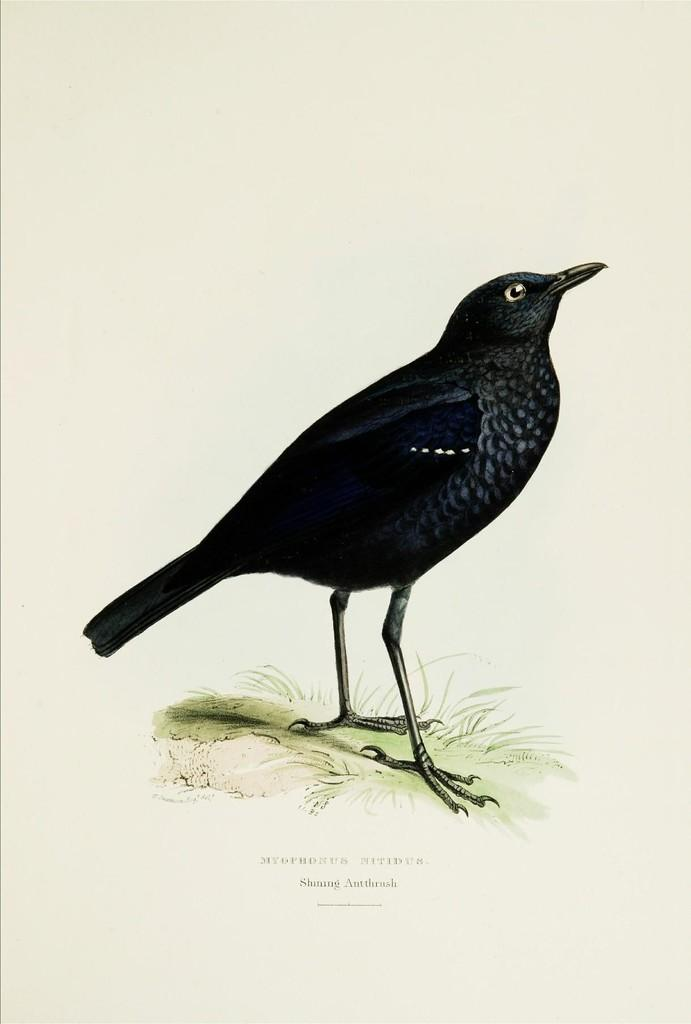What is the main subject of the picture? The main subject of the picture is an image of a crow. What type of vegetation is present in the picture? There is grass in the picture. What can be found at the bottom of the picture? There is text at the bottom of the picture. What color is the background of the image? The background of the image is cream-colored. How many cherries are hanging from the crow's beak in the image? There are no cherries present in the image, and the crow's beak is not shown holding any cherries. What type of animal is interacting with the crow in the image? There is no other animal interacting with the crow in the image; it is the only animal depicted. 